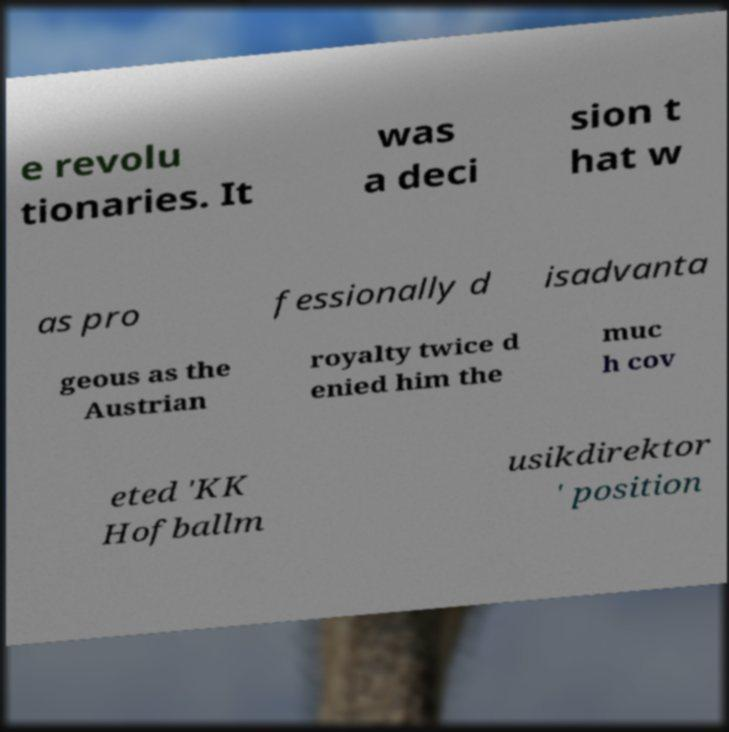Can you read and provide the text displayed in the image?This photo seems to have some interesting text. Can you extract and type it out for me? e revolu tionaries. It was a deci sion t hat w as pro fessionally d isadvanta geous as the Austrian royalty twice d enied him the muc h cov eted 'KK Hofballm usikdirektor ' position 